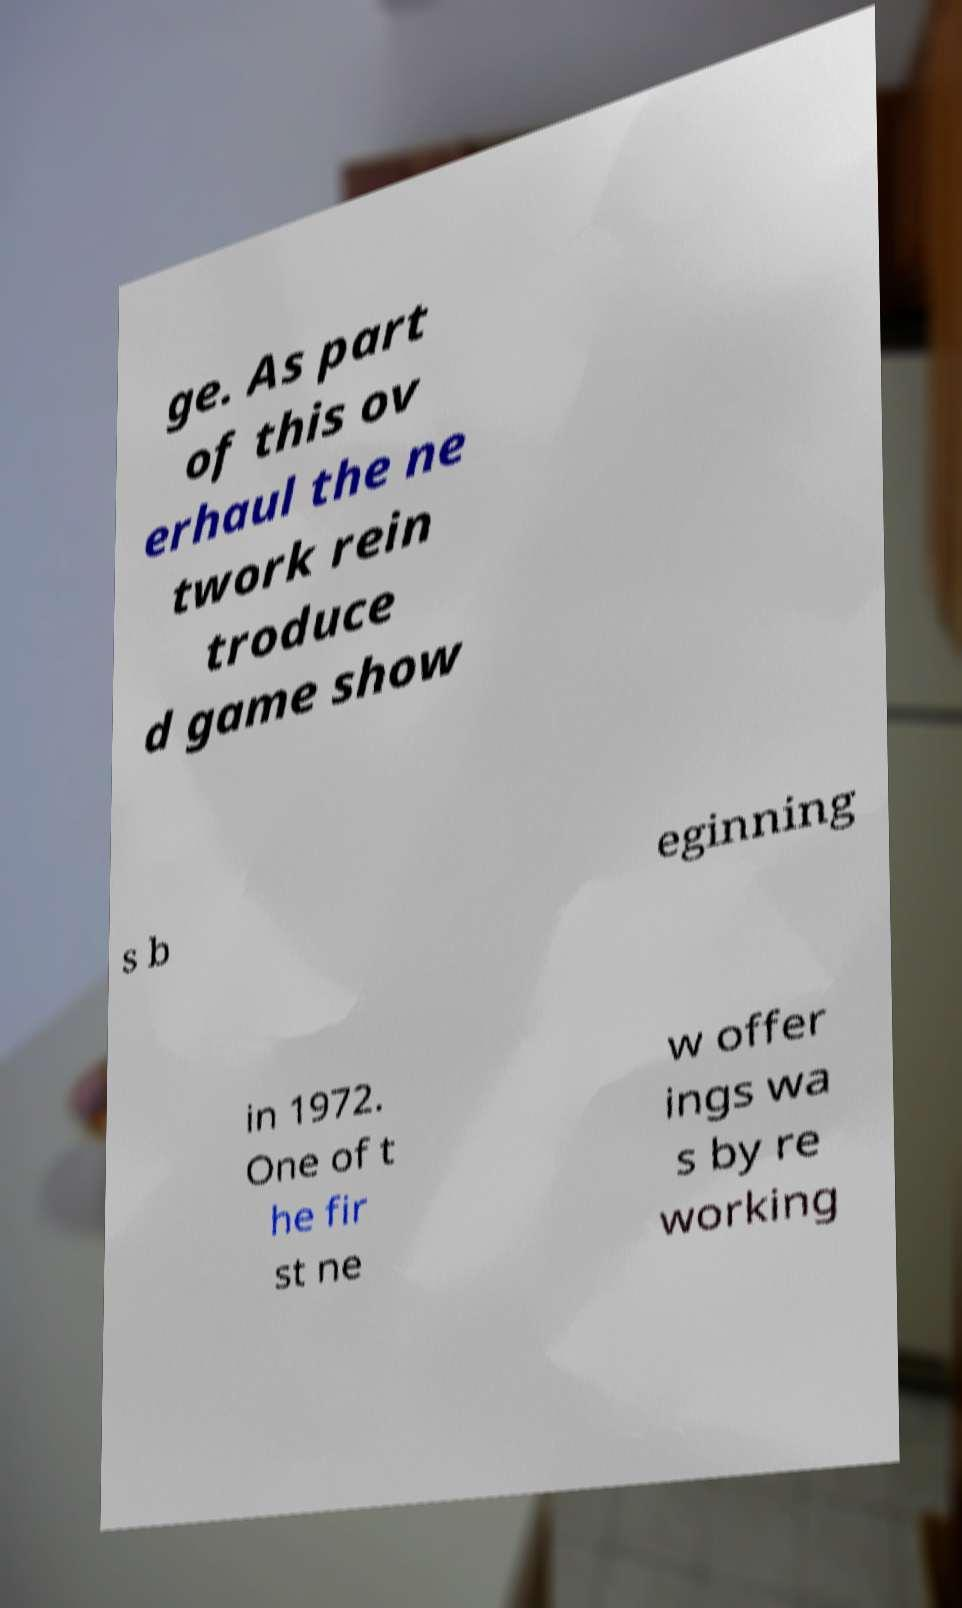Please identify and transcribe the text found in this image. ge. As part of this ov erhaul the ne twork rein troduce d game show s b eginning in 1972. One of t he fir st ne w offer ings wa s by re working 